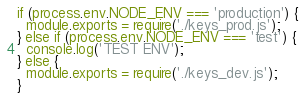<code> <loc_0><loc_0><loc_500><loc_500><_JavaScript_>if (process.env.NODE_ENV === 'production') {
  module.exports = require('./keys_prod.js');
} else if (process.env.NODE_ENV === 'test') {
  console.log('TEST ENV');
} else {
  module.exports = require('./keys_dev.js');
}
</code> 